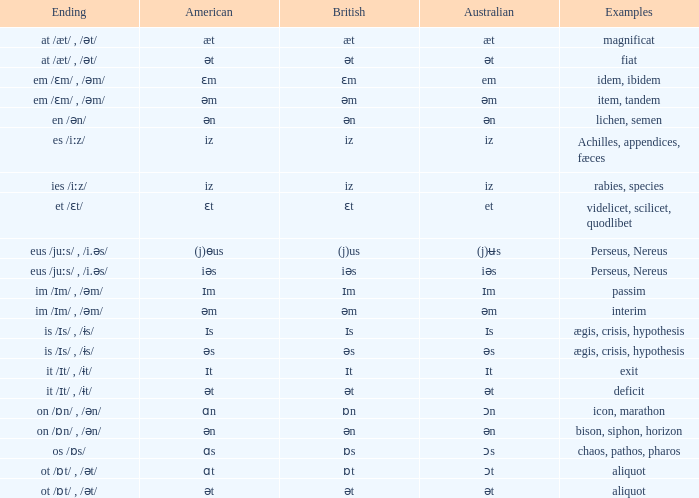Which Australian has British of ɒs? Ɔs. 